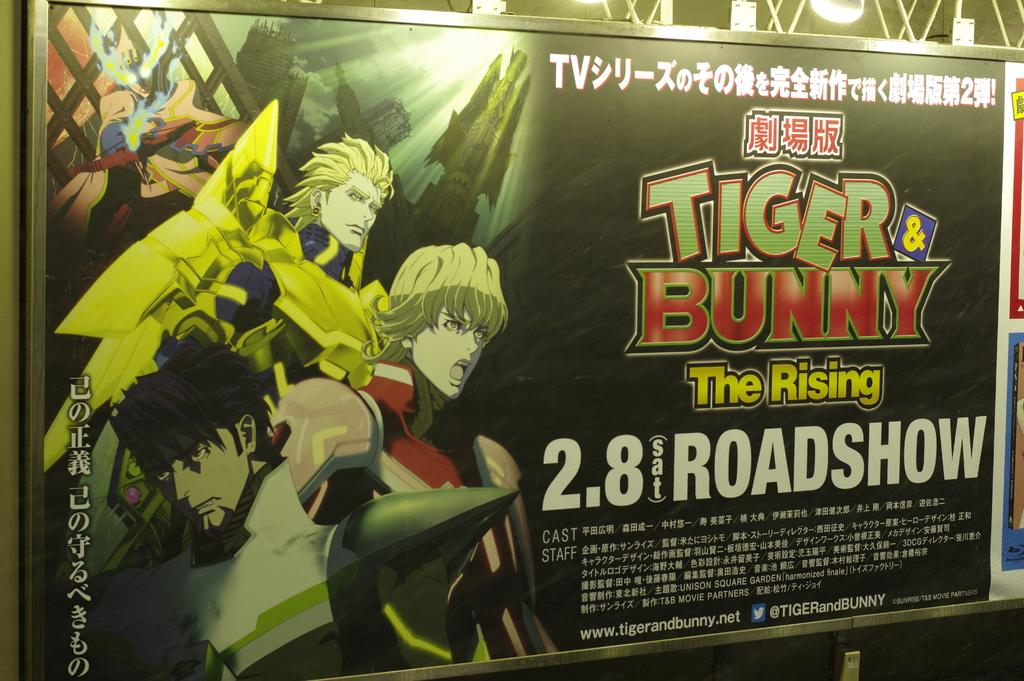<image>
Give a short and clear explanation of the subsequent image. a billboard that says 'tiger bunny the rising 2.8 sat roadshow' on it 